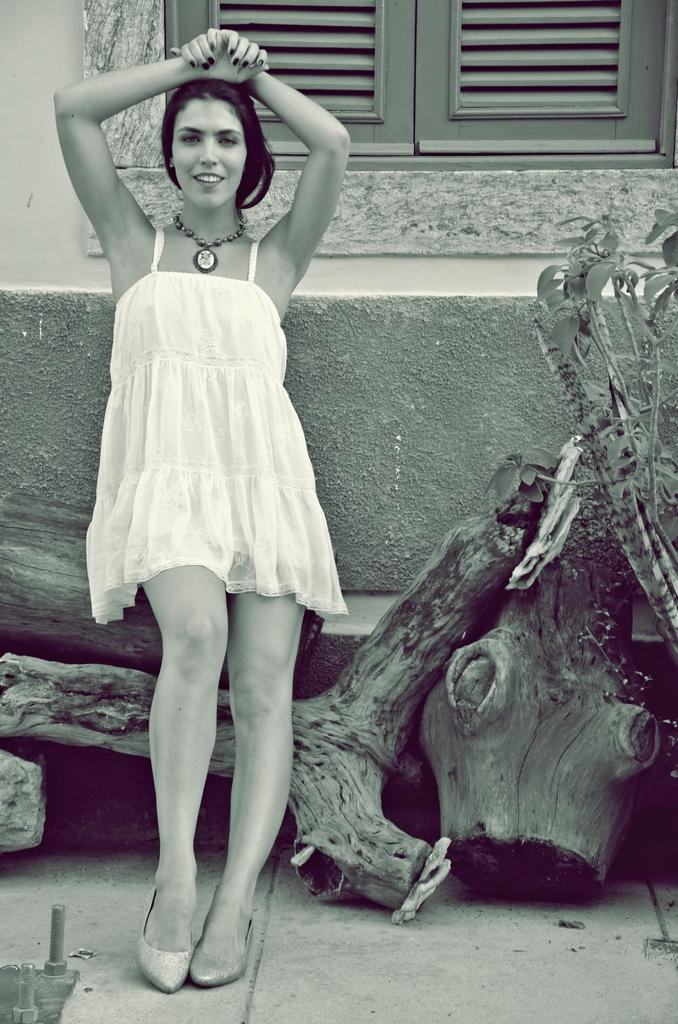What is the color scheme of the image? The image is black and white. Who is present in the image? There is a woman in the image. What is the woman's expression? The woman is smiling. What objects can be seen in the image? There are logs and a plant in the image. What can be seen in the background of the image? There is a wall and a window in the background of the image. What type of maid is depicted in the image? There is no maid present in the image. What kind of trade is being conducted in the image? There is no trade being conducted in the image. 